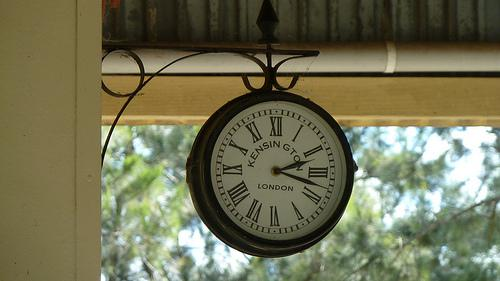Question: what has hands?
Choices:
A. A man.
B. A monkey.
C. A teenager.
D. A clock.
Answer with the letter. Answer: D Question: when was this taken?
Choices:
A. During the day time.
B. Last night.
C. Yesterday.
D. Last week.
Answer with the letter. Answer: A Question: where are the trees?
Choices:
A. In the forest.
B. In the backyard.
C. Outside the building.
D. In the ground.
Answer with the letter. Answer: C Question: how many hands?
Choices:
A. One.
B. Two.
C. Three.
D. Four.
Answer with the letter. Answer: B 